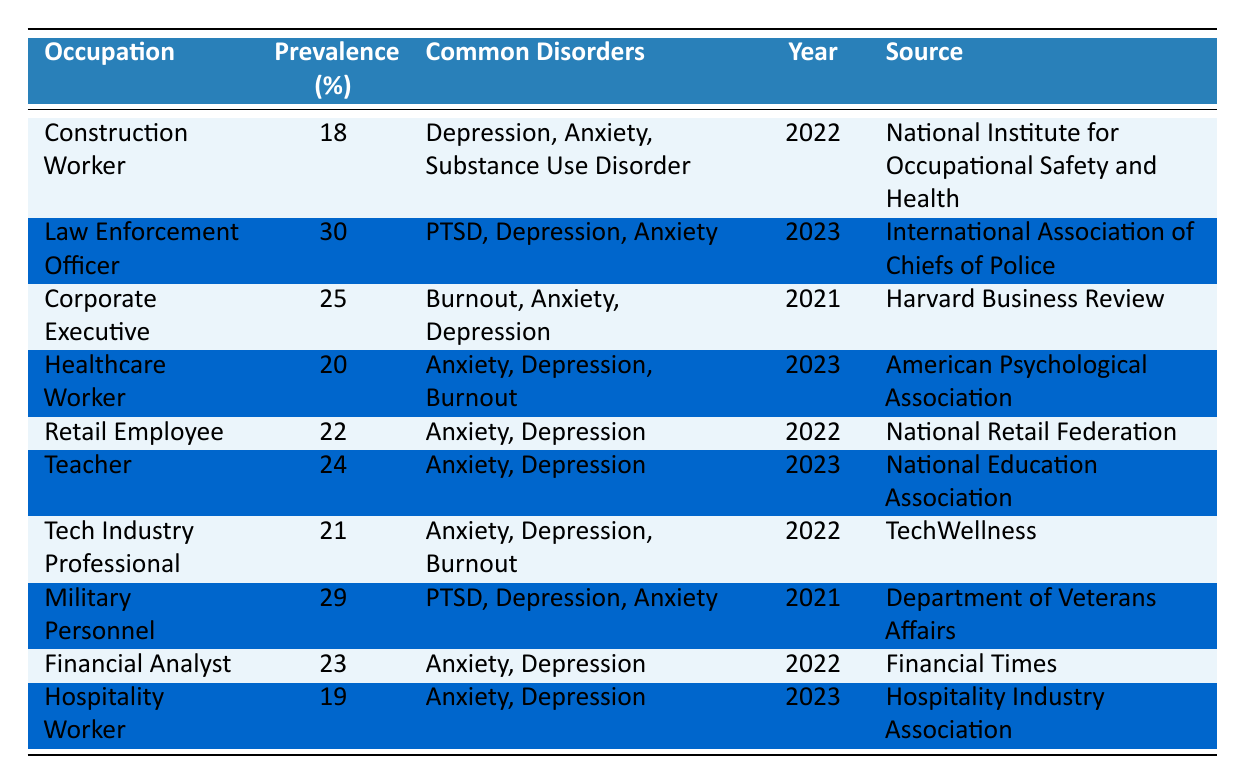What is the prevalence of mental health disorders among Law Enforcement Officers? The table indicates that the prevalence for Law Enforcement Officers is 30%.
Answer: 30% Which occupation has the highest prevalence of mental health disorders? The table shows that Law Enforcement Officers have the highest prevalence at 30%.
Answer: Law Enforcement Officer What are the common disorders reported by Construction Workers? The table lists Depression, Anxiety, and Substance Use Disorder as the common disorders for Construction Workers.
Answer: Depression, Anxiety, Substance Use Disorder How many occupations reported a prevalence of 20% or higher? The table lists the occupations with a prevalence of 20% or higher as follows: Law Enforcement Officer (30%), Corporate Executive (25%), Teacher (24%), Financial Analyst (23%), Retail Employee (22%), Tech Industry Professional (21%), and Healthcare Worker (20%), totaling 7 occupations.
Answer: 7 What is the prevalence difference between Military Personnel and Hospitality Workers? The prevalence of Military Personnel is 29%, and that of Hospitality Workers is 19%. Therefore, the difference is 29% - 19% = 10%.
Answer: 10% Which common disorder appears in both the Military Personnel and Law Enforcement Officer categories? Both occupations list PTSD and Depression as common disorders, but PTSD is unique to Law Enforcement Officers. Anxiety is common in both, showing overlap.
Answer: Anxiety Is the prevalence of mental health disorders among Healthcare Workers greater than the average prevalence across all listed occupations? The average prevalence is calculated as (18 + 30 + 25 + 20 + 22 + 24 + 21 + 29 + 23 + 19) / 10 = 21. Thus, Healthcare Workers at 20% is below the average.
Answer: No Which two occupations have the same common disorders of Anxiety and Depression? Table checks show that both Retail Employee and Teacher list Anxiety and Depression as their common disorders.
Answer: Retail Employee, Teacher How many common disorders are reported for Corporate Executives? The table indicates that Corporate Executives have three common disorders: Burnout, Anxiety, and Depression.
Answer: 3 Which profession has the lowest prevalence of mental health disorders? The table shows that Construction Workers have the lowest prevalence at 18%.
Answer: Construction Worker 